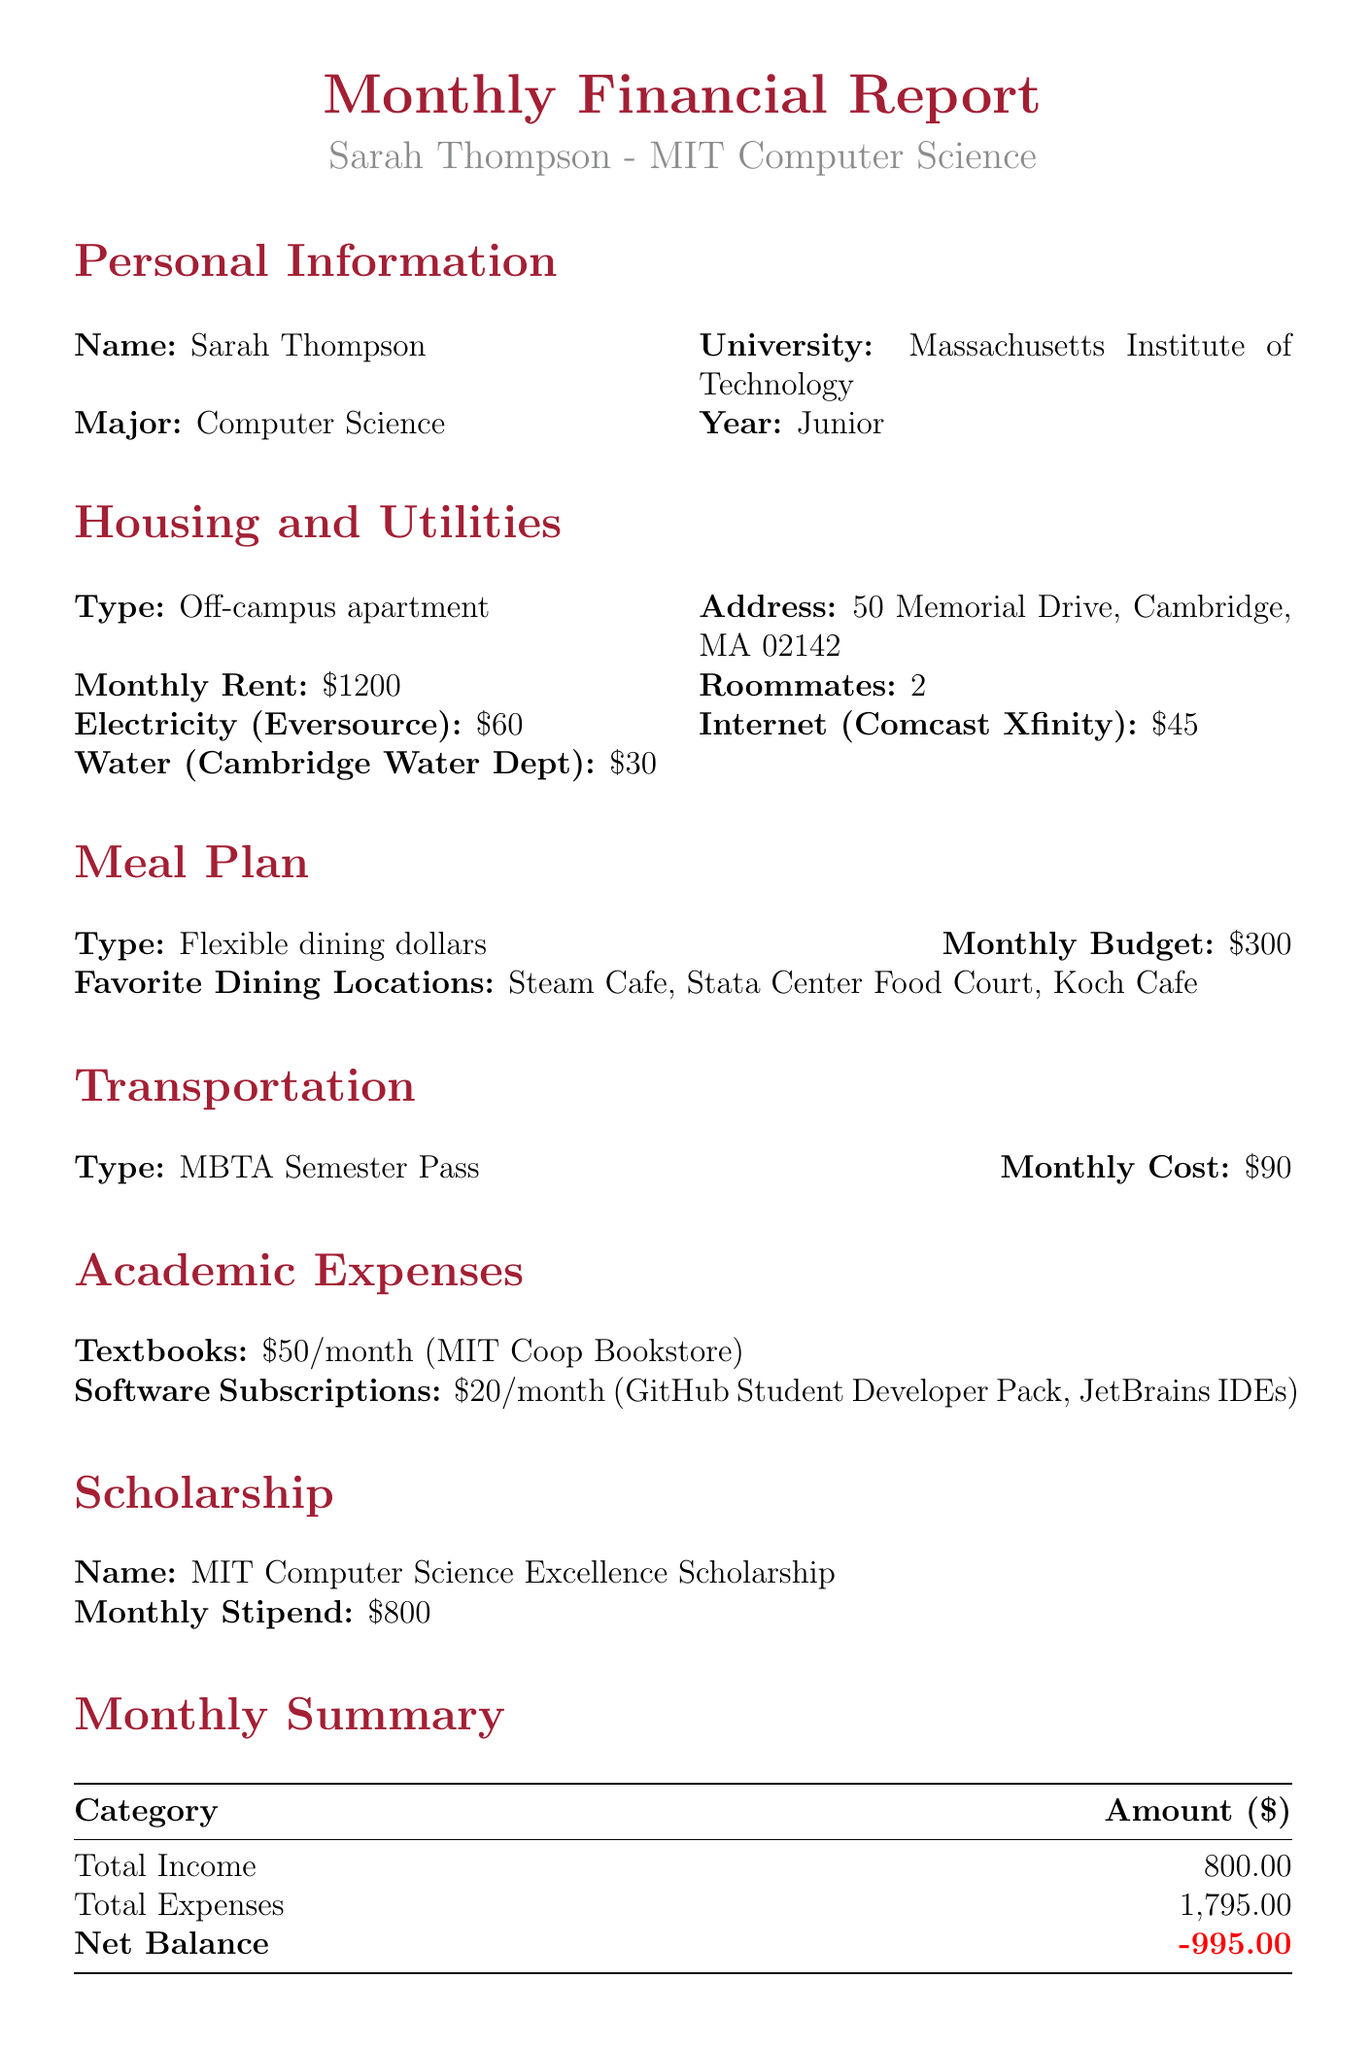What is the monthly rent for Sarah's apartment? The document states that the monthly rent for the off-campus apartment is $1200.
Answer: $1200 Who is the provider of the electricity service? According to the document, the electricity provider is Eversource.
Answer: Eversource What is the total amount of monthly expenses? The document outlines that the total expenses amount to $1795.
Answer: $1795 What is the monthly stipend from the scholarship? The document mentions that the monthly stipend from the MIT Computer Science Excellence Scholarship is $800.
Answer: $800 What are the favorite dining locations mentioned in the meal plan? The document lists Steam Cafe, Stata Center Food Court, and Koch Cafe as the favorite dining locations.
Answer: Steam Cafe, Stata Center Food Court, Koch Cafe How much does Sarah spend on transportation monthly? The monthly cost for transportation, specifically the MBTA Semester Pass, is mentioned as $90 in the document.
Answer: $90 What is the net balance at the end of the month? The document indicates that the net balance is -$995.
Answer: -$995 What items are included in the software subscriptions? The document lists GitHub Student Developer Pack and JetBrains IDEs as items in the monthly software subscriptions.
Answer: GitHub Student Developer Pack, JetBrains IDEs How many roommates does Sarah have? The document specifies that Sarah has 2 roommates in her off-campus apartment.
Answer: 2 